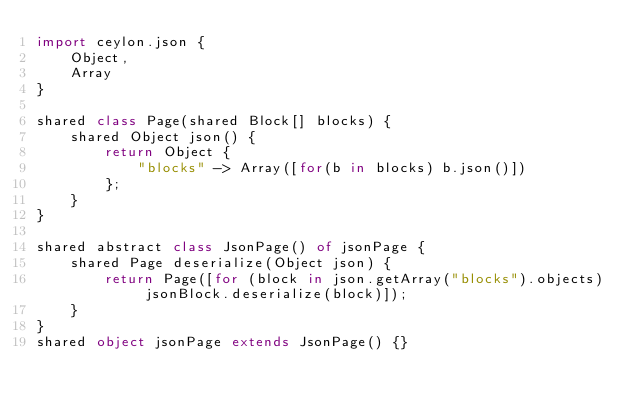<code> <loc_0><loc_0><loc_500><loc_500><_Ceylon_>import ceylon.json {
    Object,
    Array
}

shared class Page(shared Block[] blocks) {
    shared Object json() {
        return Object {
            "blocks" -> Array([for(b in blocks) b.json()])
        };
    }
}

shared abstract class JsonPage() of jsonPage {
    shared Page deserialize(Object json) {
        return Page([for (block in json.getArray("blocks").objects) jsonBlock.deserialize(block)]);
    }
}
shared object jsonPage extends JsonPage() {}
</code> 